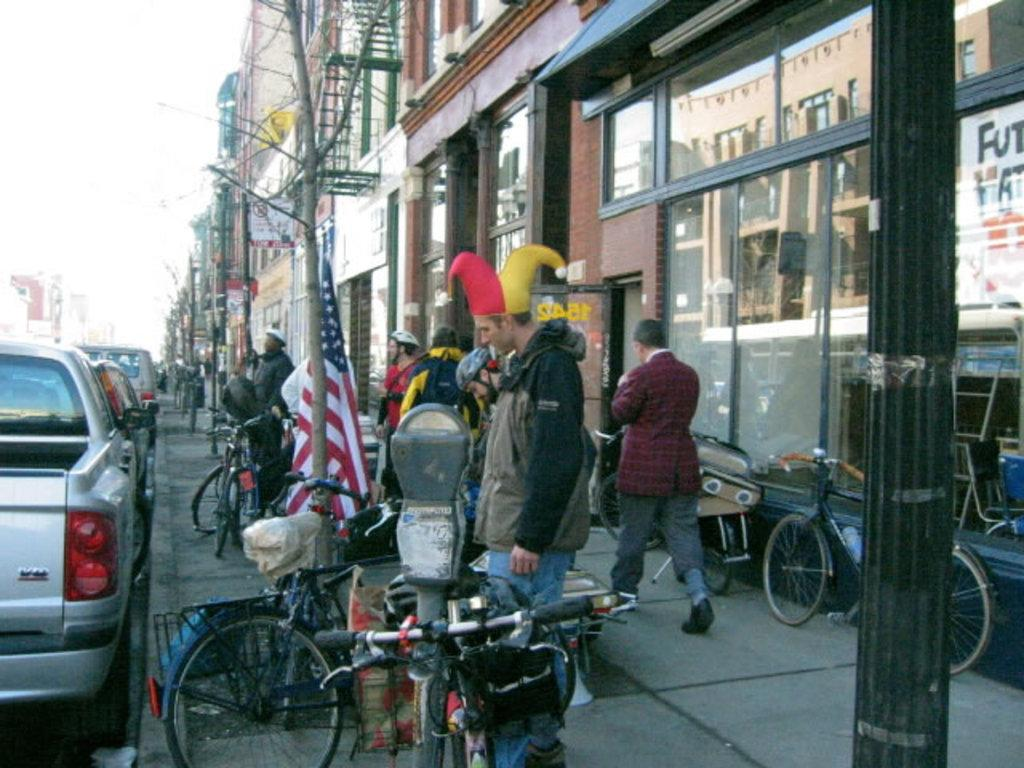What type of structures can be seen in the image? There are buildings in the image. What part of the natural environment is visible in the image? The sky is visible in the image. What type of transportation is present on the road in the image? Motor vehicles are present on the road in the image. What alternative mode of transportation can be seen in the image? Bicycles are visible in the image. What symbol or emblem is present in the image? There is a flag in the image. What type of surface are the persons standing on in the image? Persons are standing on the floor in the image. Where are the icicles hanging in the image? There are no icicles present in the image. How does the spot on the floor move in the image? There is no spot on the floor mentioned in the image, and therefore it cannot move. 